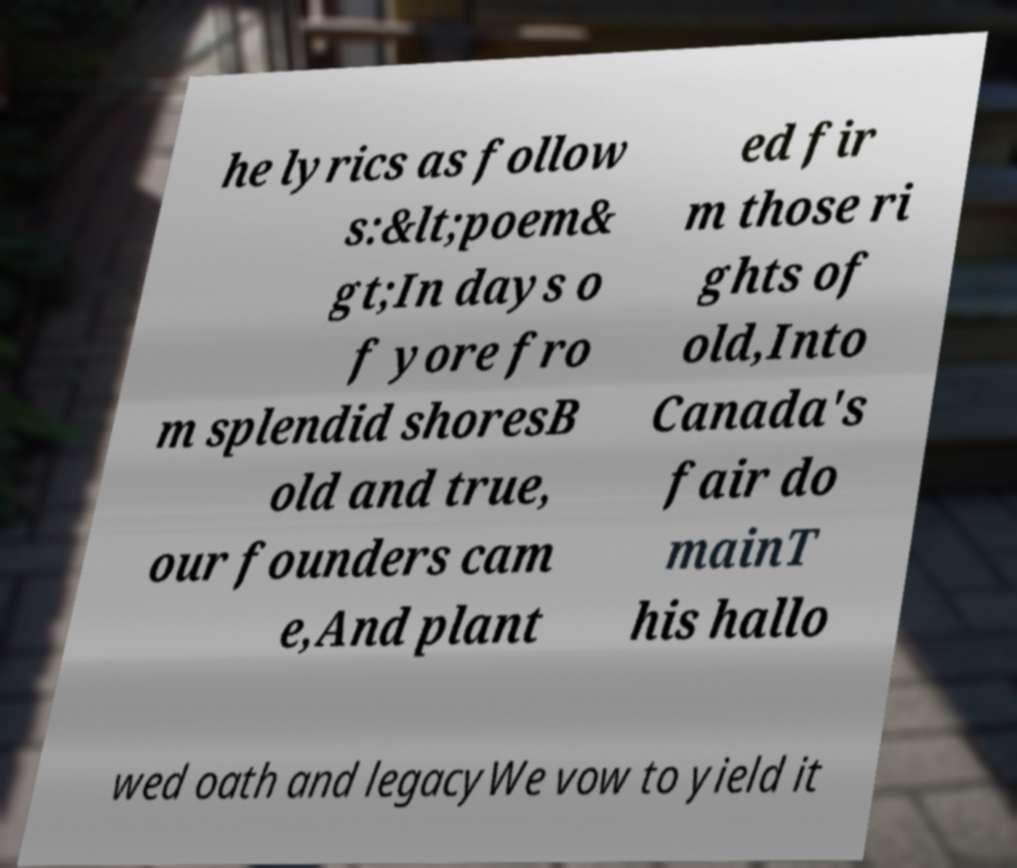Please identify and transcribe the text found in this image. he lyrics as follow s:&lt;poem& gt;In days o f yore fro m splendid shoresB old and true, our founders cam e,And plant ed fir m those ri ghts of old,Into Canada's fair do mainT his hallo wed oath and legacyWe vow to yield it 